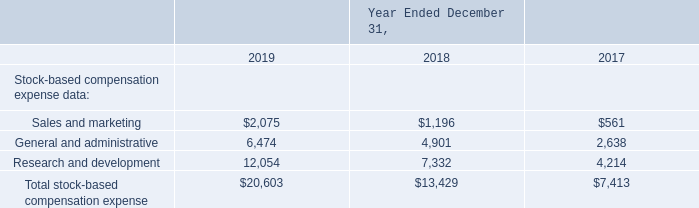Results of Operations
(2) Operating expenses include stock-based compensation expense as follows (in thousands):
What was the amount of research and development in 2017?
Answer scale should be: thousand. 4,214. What was the amount of sales and marketing in 2018?
Answer scale should be: thousand. 1,196. What years does the table provide information for total stock-based compensation expense? 2019, 2018, 2017. What was the change in sales and marketing between 2017 and 2018?
Answer scale should be: thousand. 1,196-561
Answer: 635. How many years did sales and marketing exceed $1,000 thousand? 2019##2018
Answer: 2. What was the percentage change in the amount of research and development between 2018 and 2019?
Answer scale should be: percent. (12,054-7,332)/7,332
Answer: 64.4. 